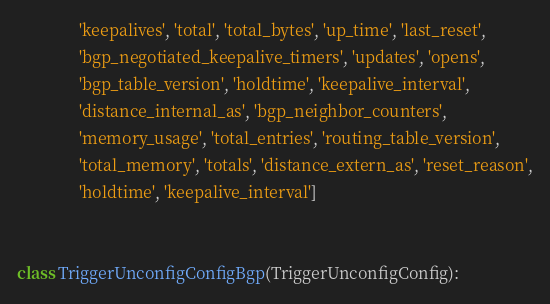Convert code to text. <code><loc_0><loc_0><loc_500><loc_500><_Python_>               'keepalives', 'total', 'total_bytes', 'up_time', 'last_reset',
               'bgp_negotiated_keepalive_timers', 'updates', 'opens',
               'bgp_table_version', 'holdtime', 'keepalive_interval',
               'distance_internal_as', 'bgp_neighbor_counters',
               'memory_usage', 'total_entries', 'routing_table_version',
               'total_memory', 'totals', 'distance_extern_as', 'reset_reason',
               'holdtime', 'keepalive_interval']


class TriggerUnconfigConfigBgp(TriggerUnconfigConfig):</code> 